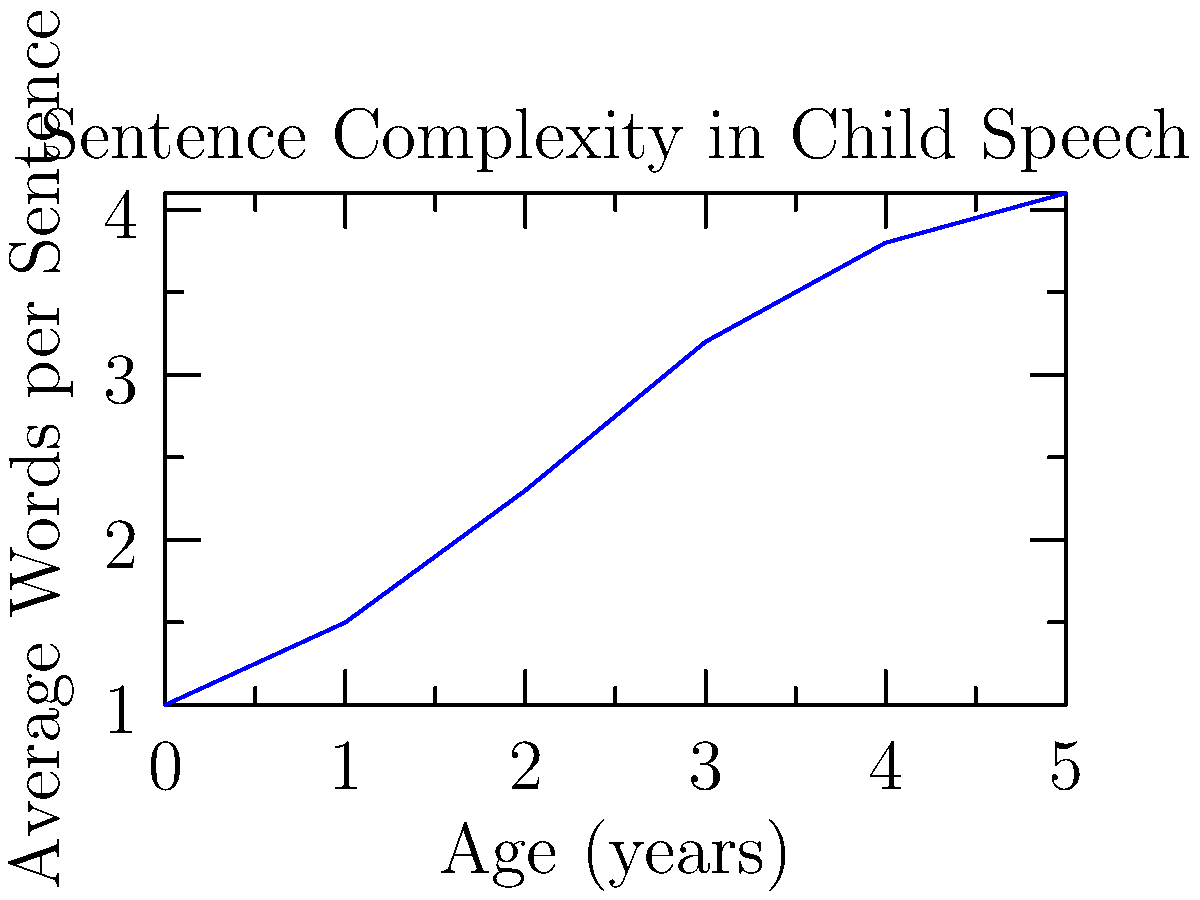Based on the line graph showing the progression of sentence complexity in child speech over time, what is the approximate increase in average words per sentence between ages 2 and 4? To determine the increase in average words per sentence between ages 2 and 4:

1. Locate the data points for age 2 and age 4 on the x-axis.
2. Find the corresponding y-axis values (average words per sentence):
   - At age 2: approximately 2.3 words
   - At age 4: approximately 3.8 words
3. Calculate the difference:
   $3.8 - 2.3 = 1.5$ words

The increase in average words per sentence from age 2 to age 4 is approximately 1.5 words.
Answer: 1.5 words 